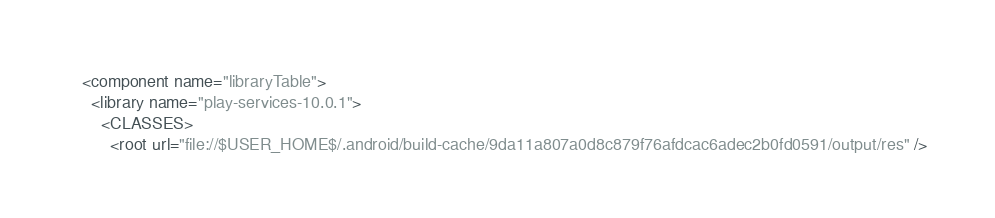Convert code to text. <code><loc_0><loc_0><loc_500><loc_500><_XML_><component name="libraryTable">
  <library name="play-services-10.0.1">
    <CLASSES>
      <root url="file://$USER_HOME$/.android/build-cache/9da11a807a0d8c879f76afdcac6adec2b0fd0591/output/res" /></code> 